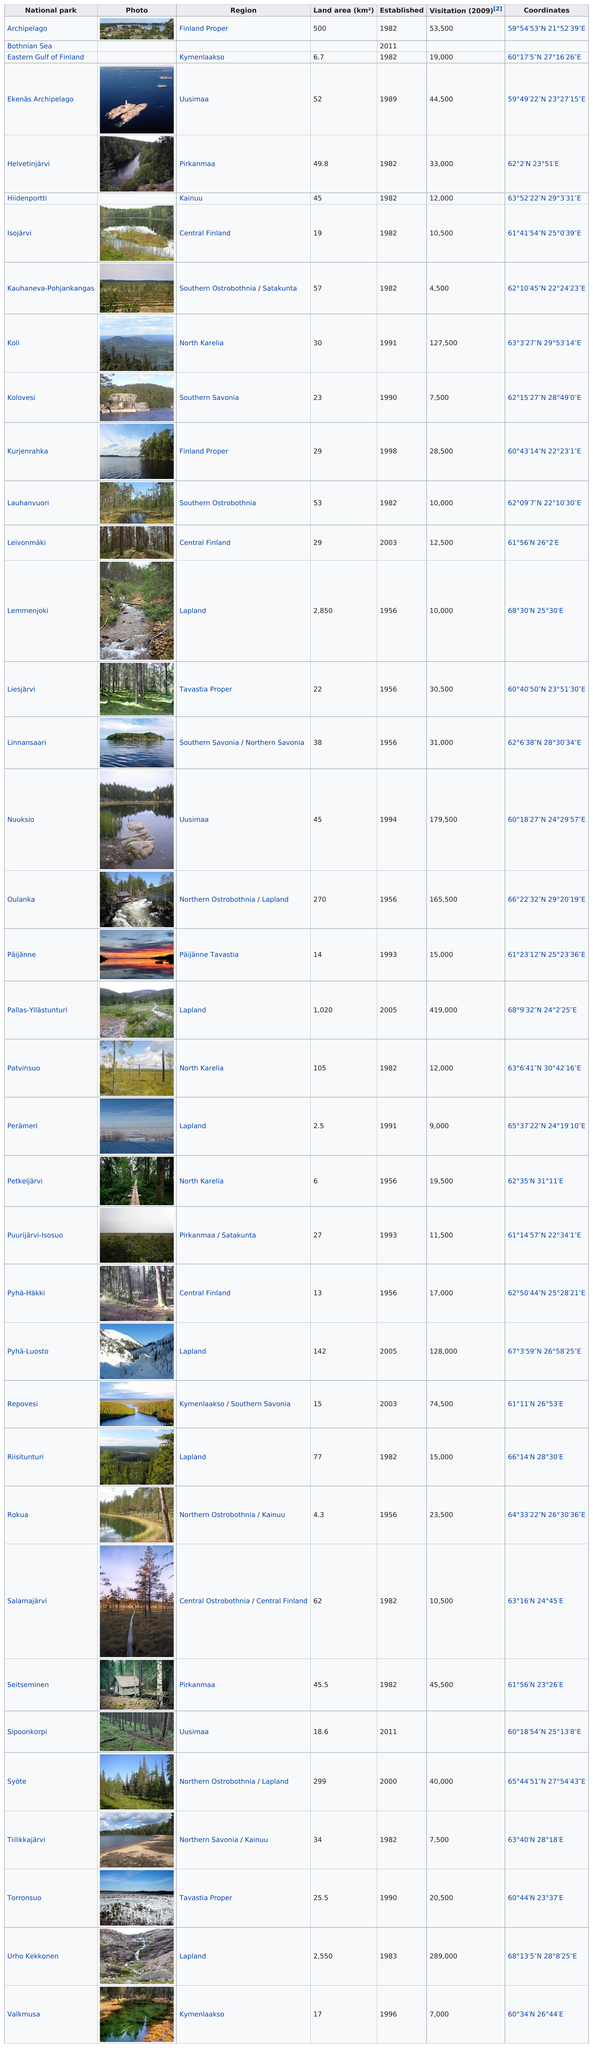Give some essential details in this illustration. Eight of Finland's national parks are greater than 100 square kilometers in size. Kauhaneva-Pohjankangas National Park in Finland has the least number of yearly visitors among all of the country's national parks. The Koli is not larger than the Lemmenjoki. There are 37 parks listed. There are 37 national parks in Finland. 